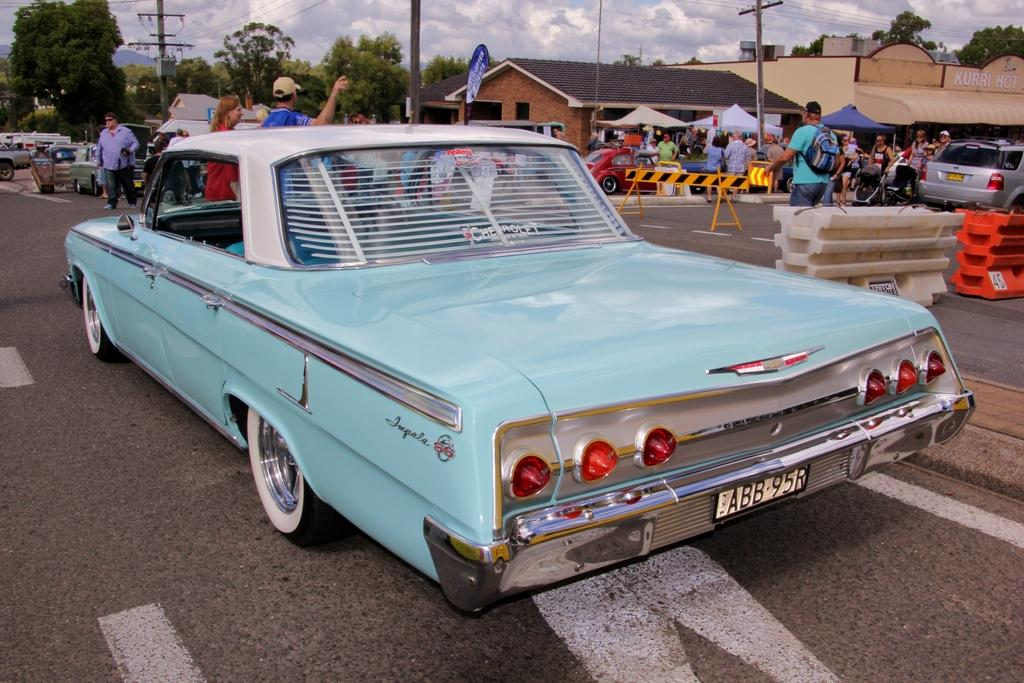What is located at the bottom of the image? There is a road at the bottom of the image. What can be seen in the middle of the image? There is a blue car in the middle of the image. What is on the right side of the image? There is a group of people, cars, and buildings on the right side of the image. What type of wine is being served to the person on the left side of the image? There is no person or wine present in the image. What trail can be seen leading up to the buildings on the right side of the image? There is no trail visible in the image; only a road, a blue car, a group of people, cars, and buildings are present. 